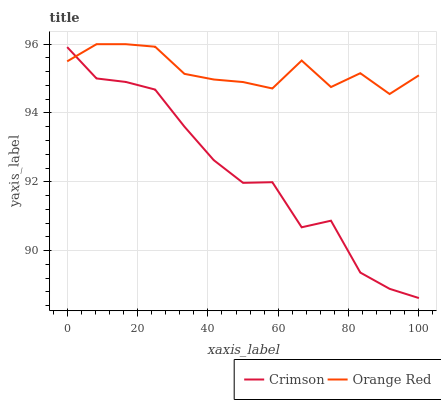Does Crimson have the minimum area under the curve?
Answer yes or no. Yes. Does Orange Red have the maximum area under the curve?
Answer yes or no. Yes. Does Orange Red have the minimum area under the curve?
Answer yes or no. No. Is Orange Red the smoothest?
Answer yes or no. Yes. Is Crimson the roughest?
Answer yes or no. Yes. Is Orange Red the roughest?
Answer yes or no. No. Does Crimson have the lowest value?
Answer yes or no. Yes. Does Orange Red have the lowest value?
Answer yes or no. No. Does Orange Red have the highest value?
Answer yes or no. Yes. Does Orange Red intersect Crimson?
Answer yes or no. Yes. Is Orange Red less than Crimson?
Answer yes or no. No. Is Orange Red greater than Crimson?
Answer yes or no. No. 